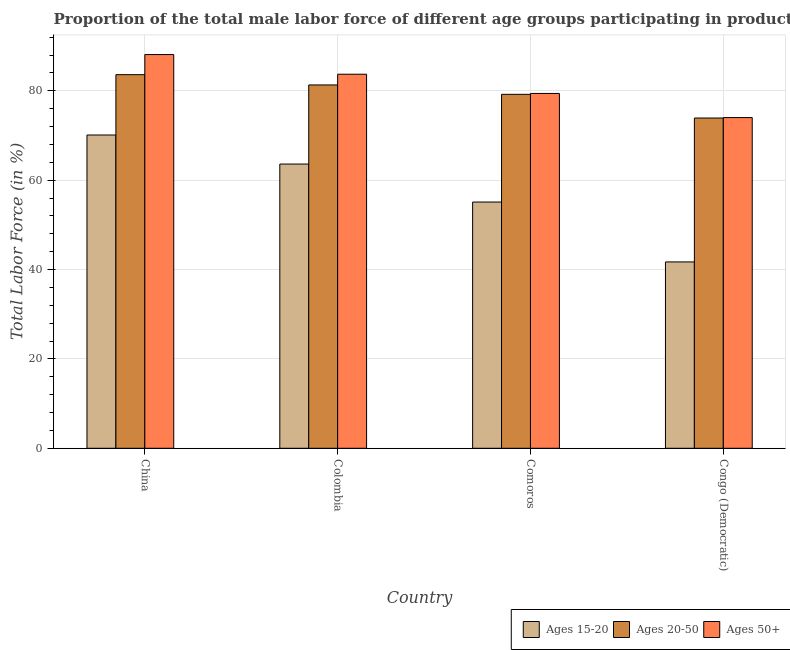How many groups of bars are there?
Provide a succinct answer. 4. How many bars are there on the 4th tick from the right?
Your answer should be very brief. 3. What is the percentage of male labor force within the age group 20-50 in Comoros?
Give a very brief answer. 79.2. Across all countries, what is the maximum percentage of male labor force within the age group 20-50?
Give a very brief answer. 83.6. Across all countries, what is the minimum percentage of male labor force within the age group 20-50?
Your answer should be compact. 73.9. In which country was the percentage of male labor force within the age group 20-50 minimum?
Your answer should be compact. Congo (Democratic). What is the total percentage of male labor force above age 50 in the graph?
Provide a short and direct response. 325.2. What is the difference between the percentage of male labor force above age 50 in Comoros and that in Congo (Democratic)?
Your response must be concise. 5.4. What is the difference between the percentage of male labor force within the age group 20-50 in China and the percentage of male labor force above age 50 in Comoros?
Make the answer very short. 4.2. What is the average percentage of male labor force above age 50 per country?
Offer a terse response. 81.3. What is the difference between the percentage of male labor force within the age group 15-20 and percentage of male labor force above age 50 in Colombia?
Keep it short and to the point. -20.1. In how many countries, is the percentage of male labor force above age 50 greater than 60 %?
Ensure brevity in your answer.  4. What is the ratio of the percentage of male labor force within the age group 20-50 in Colombia to that in Congo (Democratic)?
Provide a short and direct response. 1.1. Is the difference between the percentage of male labor force within the age group 15-20 in China and Congo (Democratic) greater than the difference between the percentage of male labor force above age 50 in China and Congo (Democratic)?
Offer a terse response. Yes. What is the difference between the highest and the second highest percentage of male labor force within the age group 15-20?
Your answer should be compact. 6.5. What is the difference between the highest and the lowest percentage of male labor force within the age group 15-20?
Make the answer very short. 28.4. Is the sum of the percentage of male labor force within the age group 20-50 in China and Colombia greater than the maximum percentage of male labor force within the age group 15-20 across all countries?
Your answer should be compact. Yes. What does the 1st bar from the left in Colombia represents?
Offer a very short reply. Ages 15-20. What does the 2nd bar from the right in Colombia represents?
Your response must be concise. Ages 20-50. Is it the case that in every country, the sum of the percentage of male labor force within the age group 15-20 and percentage of male labor force within the age group 20-50 is greater than the percentage of male labor force above age 50?
Your answer should be compact. Yes. How many bars are there?
Provide a short and direct response. 12. Are the values on the major ticks of Y-axis written in scientific E-notation?
Make the answer very short. No. Does the graph contain any zero values?
Provide a succinct answer. No. How are the legend labels stacked?
Offer a terse response. Horizontal. What is the title of the graph?
Keep it short and to the point. Proportion of the total male labor force of different age groups participating in production in 1999. Does "Transport services" appear as one of the legend labels in the graph?
Provide a short and direct response. No. What is the label or title of the X-axis?
Ensure brevity in your answer.  Country. What is the label or title of the Y-axis?
Your answer should be very brief. Total Labor Force (in %). What is the Total Labor Force (in %) of Ages 15-20 in China?
Make the answer very short. 70.1. What is the Total Labor Force (in %) in Ages 20-50 in China?
Offer a terse response. 83.6. What is the Total Labor Force (in %) of Ages 50+ in China?
Offer a very short reply. 88.1. What is the Total Labor Force (in %) in Ages 15-20 in Colombia?
Offer a very short reply. 63.6. What is the Total Labor Force (in %) of Ages 20-50 in Colombia?
Make the answer very short. 81.3. What is the Total Labor Force (in %) of Ages 50+ in Colombia?
Provide a short and direct response. 83.7. What is the Total Labor Force (in %) of Ages 15-20 in Comoros?
Your response must be concise. 55.1. What is the Total Labor Force (in %) in Ages 20-50 in Comoros?
Give a very brief answer. 79.2. What is the Total Labor Force (in %) of Ages 50+ in Comoros?
Provide a succinct answer. 79.4. What is the Total Labor Force (in %) of Ages 15-20 in Congo (Democratic)?
Your answer should be very brief. 41.7. What is the Total Labor Force (in %) in Ages 20-50 in Congo (Democratic)?
Provide a short and direct response. 73.9. Across all countries, what is the maximum Total Labor Force (in %) of Ages 15-20?
Provide a short and direct response. 70.1. Across all countries, what is the maximum Total Labor Force (in %) in Ages 20-50?
Offer a very short reply. 83.6. Across all countries, what is the maximum Total Labor Force (in %) in Ages 50+?
Provide a succinct answer. 88.1. Across all countries, what is the minimum Total Labor Force (in %) of Ages 15-20?
Offer a terse response. 41.7. Across all countries, what is the minimum Total Labor Force (in %) in Ages 20-50?
Offer a terse response. 73.9. Across all countries, what is the minimum Total Labor Force (in %) of Ages 50+?
Your response must be concise. 74. What is the total Total Labor Force (in %) of Ages 15-20 in the graph?
Your answer should be very brief. 230.5. What is the total Total Labor Force (in %) in Ages 20-50 in the graph?
Provide a short and direct response. 318. What is the total Total Labor Force (in %) of Ages 50+ in the graph?
Offer a very short reply. 325.2. What is the difference between the Total Labor Force (in %) of Ages 15-20 in China and that in Colombia?
Keep it short and to the point. 6.5. What is the difference between the Total Labor Force (in %) in Ages 50+ in China and that in Colombia?
Keep it short and to the point. 4.4. What is the difference between the Total Labor Force (in %) in Ages 15-20 in China and that in Comoros?
Keep it short and to the point. 15. What is the difference between the Total Labor Force (in %) of Ages 20-50 in China and that in Comoros?
Ensure brevity in your answer.  4.4. What is the difference between the Total Labor Force (in %) in Ages 50+ in China and that in Comoros?
Ensure brevity in your answer.  8.7. What is the difference between the Total Labor Force (in %) in Ages 15-20 in China and that in Congo (Democratic)?
Make the answer very short. 28.4. What is the difference between the Total Labor Force (in %) of Ages 50+ in China and that in Congo (Democratic)?
Give a very brief answer. 14.1. What is the difference between the Total Labor Force (in %) in Ages 20-50 in Colombia and that in Comoros?
Your answer should be compact. 2.1. What is the difference between the Total Labor Force (in %) in Ages 15-20 in Colombia and that in Congo (Democratic)?
Give a very brief answer. 21.9. What is the difference between the Total Labor Force (in %) in Ages 20-50 in Comoros and that in Congo (Democratic)?
Your answer should be very brief. 5.3. What is the difference between the Total Labor Force (in %) of Ages 50+ in Comoros and that in Congo (Democratic)?
Your answer should be compact. 5.4. What is the difference between the Total Labor Force (in %) of Ages 15-20 in China and the Total Labor Force (in %) of Ages 50+ in Colombia?
Provide a succinct answer. -13.6. What is the difference between the Total Labor Force (in %) in Ages 15-20 in China and the Total Labor Force (in %) in Ages 20-50 in Comoros?
Ensure brevity in your answer.  -9.1. What is the difference between the Total Labor Force (in %) in Ages 15-20 in China and the Total Labor Force (in %) in Ages 50+ in Comoros?
Your answer should be very brief. -9.3. What is the difference between the Total Labor Force (in %) of Ages 20-50 in China and the Total Labor Force (in %) of Ages 50+ in Congo (Democratic)?
Keep it short and to the point. 9.6. What is the difference between the Total Labor Force (in %) of Ages 15-20 in Colombia and the Total Labor Force (in %) of Ages 20-50 in Comoros?
Provide a short and direct response. -15.6. What is the difference between the Total Labor Force (in %) of Ages 15-20 in Colombia and the Total Labor Force (in %) of Ages 50+ in Comoros?
Your response must be concise. -15.8. What is the difference between the Total Labor Force (in %) in Ages 15-20 in Comoros and the Total Labor Force (in %) in Ages 20-50 in Congo (Democratic)?
Give a very brief answer. -18.8. What is the difference between the Total Labor Force (in %) in Ages 15-20 in Comoros and the Total Labor Force (in %) in Ages 50+ in Congo (Democratic)?
Provide a short and direct response. -18.9. What is the average Total Labor Force (in %) in Ages 15-20 per country?
Keep it short and to the point. 57.62. What is the average Total Labor Force (in %) in Ages 20-50 per country?
Ensure brevity in your answer.  79.5. What is the average Total Labor Force (in %) of Ages 50+ per country?
Give a very brief answer. 81.3. What is the difference between the Total Labor Force (in %) of Ages 15-20 and Total Labor Force (in %) of Ages 20-50 in China?
Ensure brevity in your answer.  -13.5. What is the difference between the Total Labor Force (in %) in Ages 20-50 and Total Labor Force (in %) in Ages 50+ in China?
Give a very brief answer. -4.5. What is the difference between the Total Labor Force (in %) of Ages 15-20 and Total Labor Force (in %) of Ages 20-50 in Colombia?
Ensure brevity in your answer.  -17.7. What is the difference between the Total Labor Force (in %) of Ages 15-20 and Total Labor Force (in %) of Ages 50+ in Colombia?
Provide a short and direct response. -20.1. What is the difference between the Total Labor Force (in %) in Ages 15-20 and Total Labor Force (in %) in Ages 20-50 in Comoros?
Your answer should be compact. -24.1. What is the difference between the Total Labor Force (in %) in Ages 15-20 and Total Labor Force (in %) in Ages 50+ in Comoros?
Ensure brevity in your answer.  -24.3. What is the difference between the Total Labor Force (in %) of Ages 20-50 and Total Labor Force (in %) of Ages 50+ in Comoros?
Offer a very short reply. -0.2. What is the difference between the Total Labor Force (in %) of Ages 15-20 and Total Labor Force (in %) of Ages 20-50 in Congo (Democratic)?
Provide a succinct answer. -32.2. What is the difference between the Total Labor Force (in %) of Ages 15-20 and Total Labor Force (in %) of Ages 50+ in Congo (Democratic)?
Make the answer very short. -32.3. What is the difference between the Total Labor Force (in %) in Ages 20-50 and Total Labor Force (in %) in Ages 50+ in Congo (Democratic)?
Provide a succinct answer. -0.1. What is the ratio of the Total Labor Force (in %) of Ages 15-20 in China to that in Colombia?
Offer a terse response. 1.1. What is the ratio of the Total Labor Force (in %) in Ages 20-50 in China to that in Colombia?
Provide a succinct answer. 1.03. What is the ratio of the Total Labor Force (in %) of Ages 50+ in China to that in Colombia?
Provide a succinct answer. 1.05. What is the ratio of the Total Labor Force (in %) of Ages 15-20 in China to that in Comoros?
Give a very brief answer. 1.27. What is the ratio of the Total Labor Force (in %) of Ages 20-50 in China to that in Comoros?
Offer a terse response. 1.06. What is the ratio of the Total Labor Force (in %) in Ages 50+ in China to that in Comoros?
Provide a short and direct response. 1.11. What is the ratio of the Total Labor Force (in %) of Ages 15-20 in China to that in Congo (Democratic)?
Your answer should be compact. 1.68. What is the ratio of the Total Labor Force (in %) in Ages 20-50 in China to that in Congo (Democratic)?
Your answer should be compact. 1.13. What is the ratio of the Total Labor Force (in %) in Ages 50+ in China to that in Congo (Democratic)?
Provide a succinct answer. 1.19. What is the ratio of the Total Labor Force (in %) in Ages 15-20 in Colombia to that in Comoros?
Offer a very short reply. 1.15. What is the ratio of the Total Labor Force (in %) in Ages 20-50 in Colombia to that in Comoros?
Give a very brief answer. 1.03. What is the ratio of the Total Labor Force (in %) of Ages 50+ in Colombia to that in Comoros?
Your response must be concise. 1.05. What is the ratio of the Total Labor Force (in %) of Ages 15-20 in Colombia to that in Congo (Democratic)?
Give a very brief answer. 1.53. What is the ratio of the Total Labor Force (in %) of Ages 20-50 in Colombia to that in Congo (Democratic)?
Provide a succinct answer. 1.1. What is the ratio of the Total Labor Force (in %) of Ages 50+ in Colombia to that in Congo (Democratic)?
Give a very brief answer. 1.13. What is the ratio of the Total Labor Force (in %) of Ages 15-20 in Comoros to that in Congo (Democratic)?
Your answer should be compact. 1.32. What is the ratio of the Total Labor Force (in %) of Ages 20-50 in Comoros to that in Congo (Democratic)?
Your response must be concise. 1.07. What is the ratio of the Total Labor Force (in %) of Ages 50+ in Comoros to that in Congo (Democratic)?
Offer a very short reply. 1.07. What is the difference between the highest and the second highest Total Labor Force (in %) of Ages 20-50?
Provide a succinct answer. 2.3. What is the difference between the highest and the second highest Total Labor Force (in %) in Ages 50+?
Give a very brief answer. 4.4. What is the difference between the highest and the lowest Total Labor Force (in %) in Ages 15-20?
Keep it short and to the point. 28.4. What is the difference between the highest and the lowest Total Labor Force (in %) in Ages 50+?
Provide a short and direct response. 14.1. 